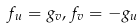<formula> <loc_0><loc_0><loc_500><loc_500>{ { f } _ { u } } = { { g } _ { v } } , { { f } _ { v } } = - { { g } _ { u } }</formula> 